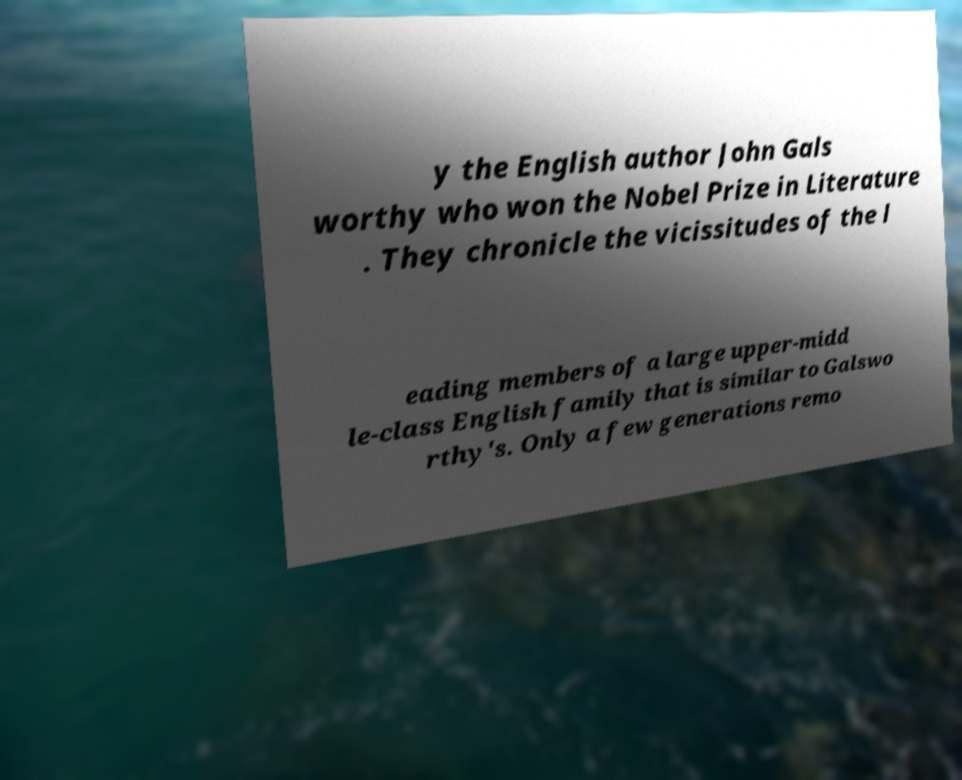Could you extract and type out the text from this image? y the English author John Gals worthy who won the Nobel Prize in Literature . They chronicle the vicissitudes of the l eading members of a large upper-midd le-class English family that is similar to Galswo rthy's. Only a few generations remo 